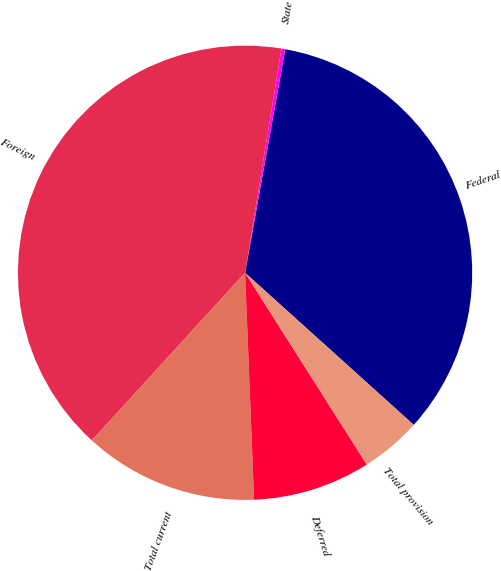<chart> <loc_0><loc_0><loc_500><loc_500><pie_chart><fcel>Federal<fcel>State<fcel>Foreign<fcel>Total current<fcel>Deferred<fcel>Total provision<nl><fcel>33.85%<fcel>0.27%<fcel>40.78%<fcel>12.42%<fcel>8.37%<fcel>4.32%<nl></chart> 